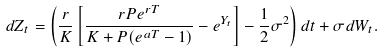<formula> <loc_0><loc_0><loc_500><loc_500>d Z _ { t } = \left ( \frac { r } { K } \left [ \frac { r P e ^ { r T } } { K + P ( e ^ { a T } - 1 ) } - e ^ { Y _ { t } } \right ] - \frac { 1 } { 2 } \sigma ^ { 2 } \right ) d t + \sigma d W _ { t } .</formula> 